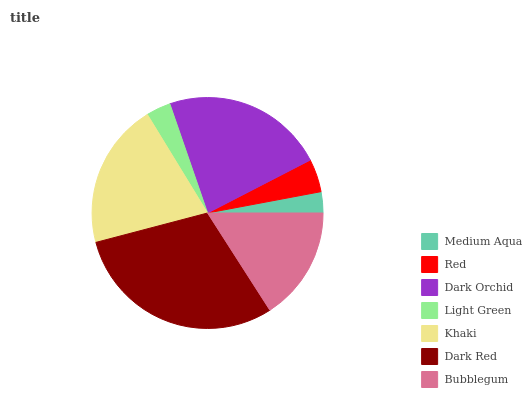Is Medium Aqua the minimum?
Answer yes or no. Yes. Is Dark Red the maximum?
Answer yes or no. Yes. Is Red the minimum?
Answer yes or no. No. Is Red the maximum?
Answer yes or no. No. Is Red greater than Medium Aqua?
Answer yes or no. Yes. Is Medium Aqua less than Red?
Answer yes or no. Yes. Is Medium Aqua greater than Red?
Answer yes or no. No. Is Red less than Medium Aqua?
Answer yes or no. No. Is Bubblegum the high median?
Answer yes or no. Yes. Is Bubblegum the low median?
Answer yes or no. Yes. Is Red the high median?
Answer yes or no. No. Is Medium Aqua the low median?
Answer yes or no. No. 